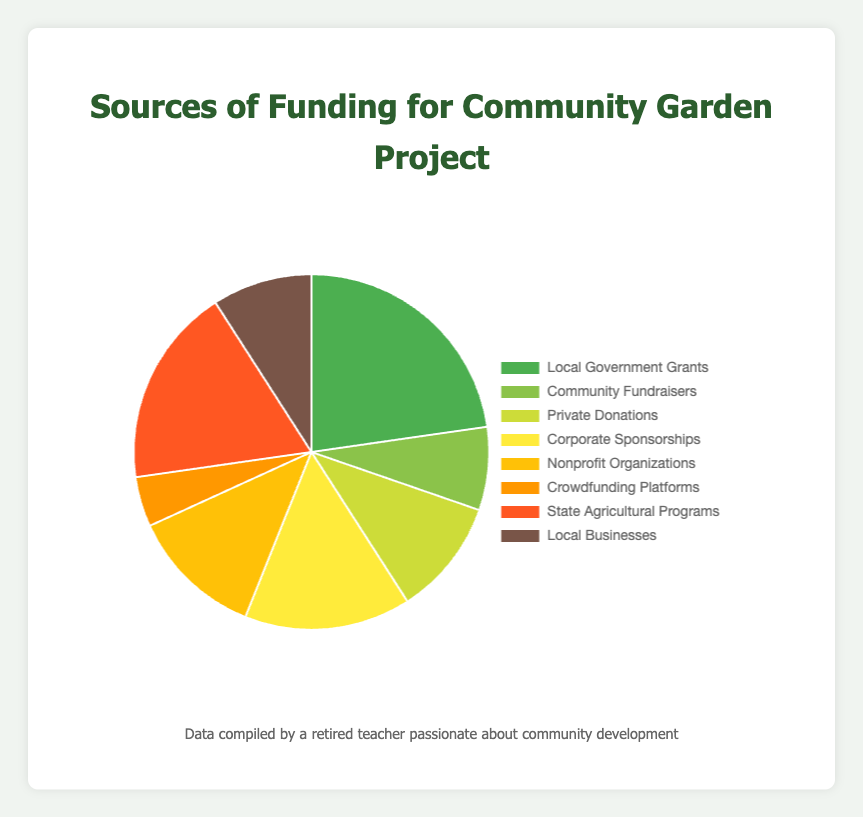What is the largest source of funding for the community garden project? The pie chart visually represents that "Local Government Grants" has the largest slice among all the sources of funding.
Answer: Local Government Grants How much more funding does "Local Government Grants" provide compared to "Community Fundraisers"? "Local Government Grants" provides $15,000 while "Community Fundraisers" provides $5,000. Subtracting $5,000 from $15,000 gives $10,000.
Answer: $10,000 Which source provides the least amount of funding? The smallest slice in the pie chart corresponds to "Crowdfunding Platforms" which funds $3,000.
Answer: Crowdfunding Platforms How does the funding from "State Agricultural Programs" compare to "Local Businesses"? The pie chart slice representation reveals that "State Agricultural Programs" funds $12,000, which is more than the $6,000 funded by "Local Businesses".
Answer: More What is the total amount of funding provided by "Private Donations" and "Nonprofit Organizations"? "Private Donations" provides $7,000 and "Nonprofit Organizations" provides $8,000. Adding these amounts results in $15,000.
Answer: $15,000 Which funding sources contribute exactly $10,000 each? The pie chart shows that "Corporate Sponsorships" is the only source contributing exactly $10,000.
Answer: Corporate Sponsorships What is the percentage of funding provided by "Local Government Grants" out of the total funding? The total funding is the sum of all sources: $15,000 + $5,000 + $7,000 + $10,000 + $8,000 + $3,000 + $12,000 + $6,000 = $66,000. The percentage is calculated as ($15,000 / $66,000) * 100% ≈ 22.7%.
Answer: 22.7% Compare the combined funding from "Community Fundraisers" and "Crowdfunding Platforms" to "Corporate Sponsorships". "Community Fundraisers" provides $5,000 and "Crowdfunding Platforms" provides $3,000. Combined, they provide $8,000. "Corporate Sponsorships" alone provide $10,000. Combined funding from the former is less than the latter.
Answer: Less What is the difference in funding between "Nonprofit Organizations" and "Local Businesses"? "Nonprofit Organizations" provide $8,000 while "Local Businesses" provide $6,000. The difference is $8,000 - $6,000 which equals $2,000.
Answer: $2,000 What is the average amount of funding contributed by all sources? Sum all funding amounts to get $66,000 and divide by the number of sources (8). The average is $66,000 / 8 = $8,250.
Answer: $8,250 